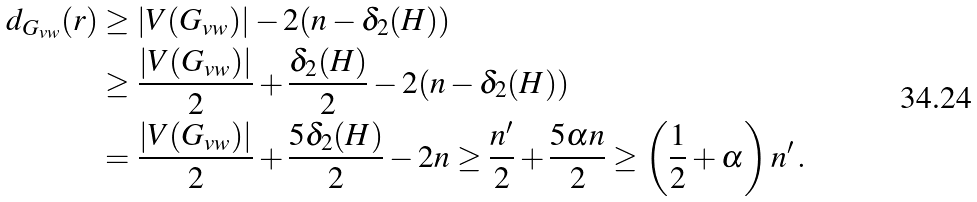Convert formula to latex. <formula><loc_0><loc_0><loc_500><loc_500>d _ { G _ { v w } } ( r ) & \geq | V ( G _ { v w } ) | - 2 ( n - \delta _ { 2 } ( H ) ) \\ & \geq \frac { | V ( G _ { v w } ) | } { 2 } + \frac { \delta _ { 2 } ( H ) } { 2 } - 2 ( n - \delta _ { 2 } ( H ) ) \\ & = \frac { | V ( G _ { v w } ) | } { 2 } + \frac { 5 \delta _ { 2 } ( H ) } { 2 } - 2 n \geq \frac { n ^ { \prime } } { 2 } + \frac { 5 \alpha n } { 2 } \geq \left ( \frac { 1 } { 2 } + \alpha \right ) n ^ { \prime } \, .</formula> 